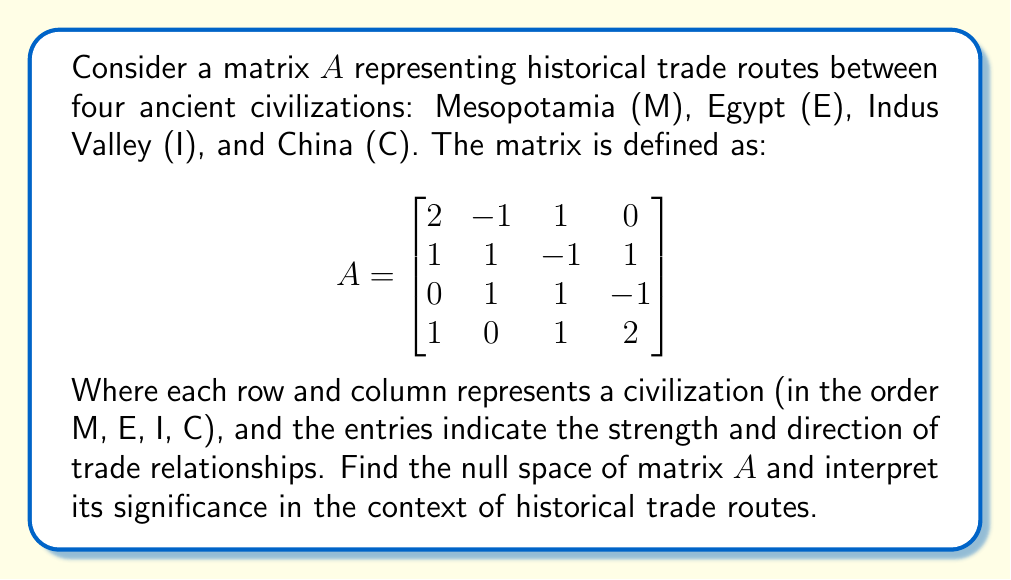Give your solution to this math problem. To find the null space of matrix $A$, we need to solve the homogeneous equation $A\mathbf{x} = \mathbf{0}$, where $\mathbf{x}$ is a vector in $\mathbb{R}^4$.

Step 1: Set up the augmented matrix $[A|\mathbf{0}]$:
$$\left[\begin{array}{cccc|c}
2 & -1 & 1 & 0 & 0 \\
1 & 1 & -1 & 1 & 0 \\
0 & 1 & 1 & -1 & 0 \\
1 & 0 & 1 & 2 & 0
\end{array}\right]$$

Step 2: Perform Gaussian elimination to obtain row echelon form:
$$\left[\begin{array}{cccc|c}
1 & 0 & 0 & 1 & 0 \\
0 & 1 & 0 & -1 & 0 \\
0 & 0 & 1 & 1 & 0 \\
0 & 0 & 0 & 0 & 0
\end{array}\right]$$

Step 3: From the row echelon form, we can express the solution as:
$$\begin{align}
x_1 &= -x_4 \\
x_2 &= x_4 \\
x_3 &= -x_4 \\
x_4 &= t \quad \text{(free variable)}
\end{align}$$

Step 4: Write the general solution as a vector:
$$\mathbf{x} = t\begin{bmatrix} -1 \\ 1 \\ -1 \\ 1 \end{bmatrix}, \quad t \in \mathbb{R}$$

The null space of $A$ is the span of this vector.

Interpretation: The null space represents a balanced trade configuration where the net effect on each civilization's economy is zero. In this case, it suggests a cyclical trade pattern where:
1. Mesopotamia exports to Egypt
2. Egypt exports to China
3. China exports to Indus Valley
4. Indus Valley exports to Mesopotamia

This cycle creates a balanced flow of goods and resources, with each civilization both importing and exporting in equal measure, resulting in no net gain or loss for any individual civilization.
Answer: The null space of matrix $A$ is:

$$\text{Null}(A) = \text{span}\left\{\begin{bmatrix} -1 \\ 1 \\ -1 \\ 1 \end{bmatrix}\right\}$$

This represents a balanced cyclical trade pattern among the four civilizations, where each civilization's exports are balanced by its imports, resulting in no net economic impact on any individual civilization. 